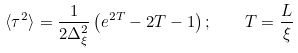<formula> <loc_0><loc_0><loc_500><loc_500>\langle \tau ^ { 2 } \rangle = \frac { 1 } { 2 \Delta _ { \xi } ^ { 2 } } \left ( e ^ { 2 T } - 2 T - 1 \right ) ; \quad T = \frac { L } { \xi }</formula> 